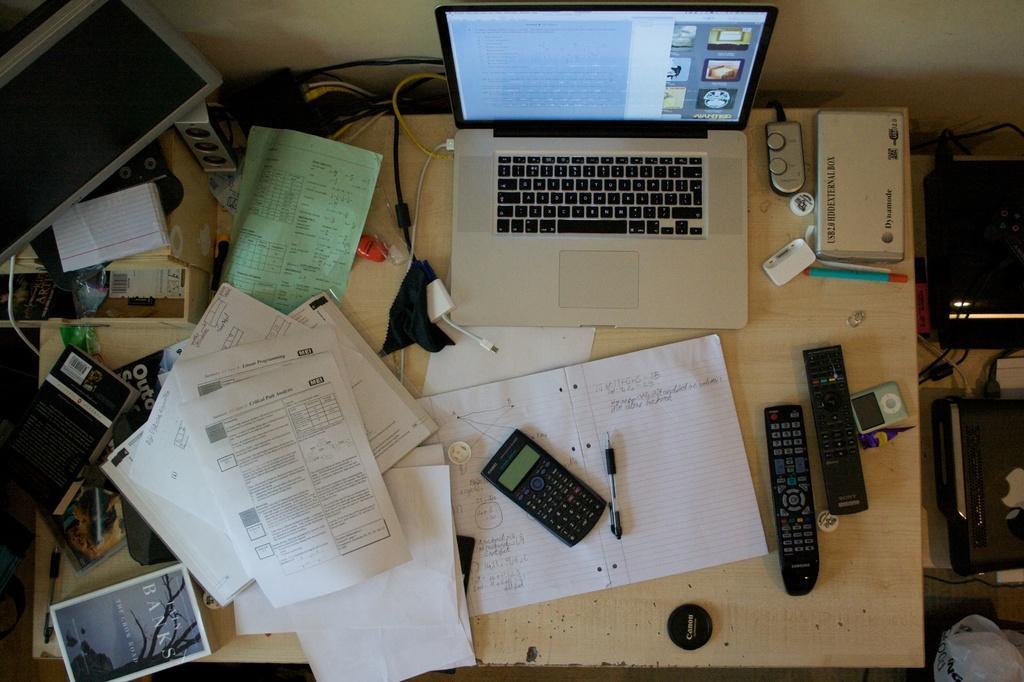In one or two sentences, can you explain what this image depicts? In this picture i could see a white colored table on the white color table there is a modem and a laptop and some cables in the back, and papers, book, calculator, pen, remote controls , pod and some black color stuff to the left corner and some devices in the right of the picture and in the back ground i could see a yellow wall. 